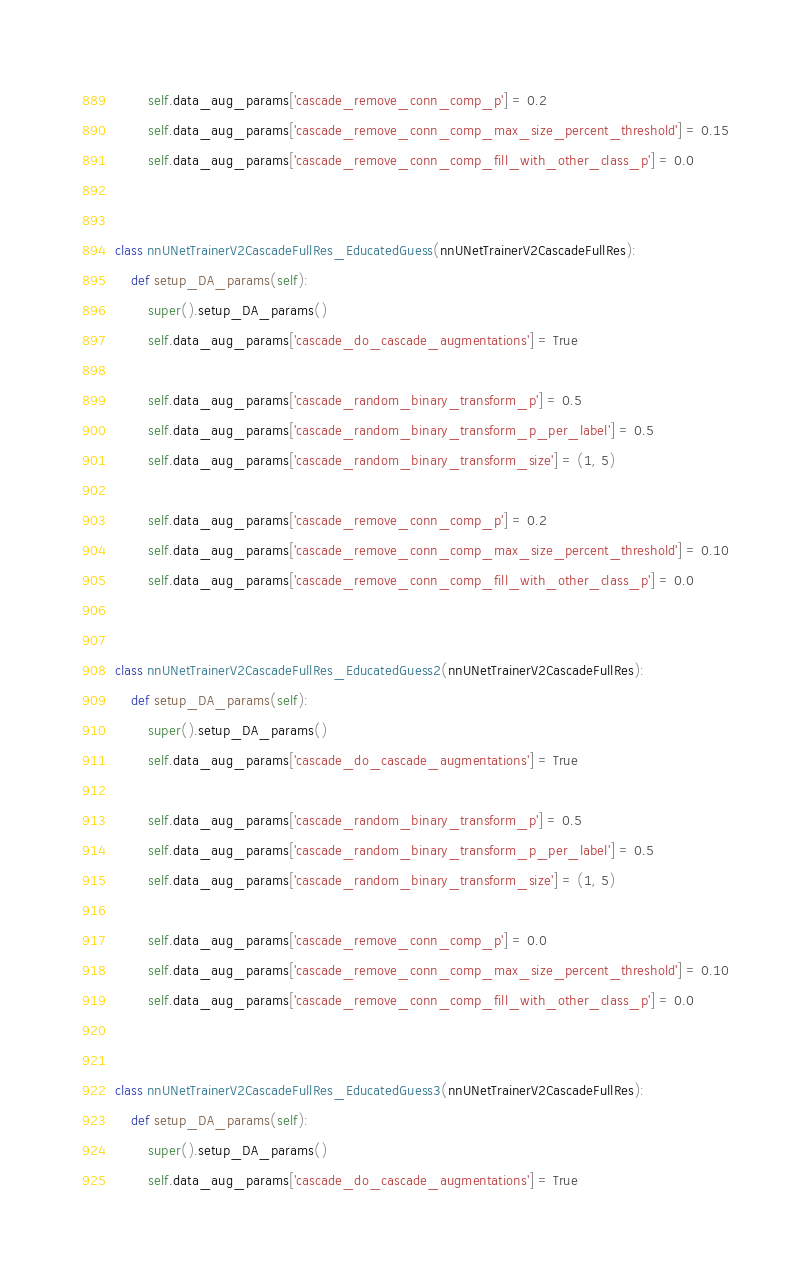<code> <loc_0><loc_0><loc_500><loc_500><_Python_>
        self.data_aug_params['cascade_remove_conn_comp_p'] = 0.2
        self.data_aug_params['cascade_remove_conn_comp_max_size_percent_threshold'] = 0.15
        self.data_aug_params['cascade_remove_conn_comp_fill_with_other_class_p'] = 0.0


class nnUNetTrainerV2CascadeFullRes_EducatedGuess(nnUNetTrainerV2CascadeFullRes):
    def setup_DA_params(self):
        super().setup_DA_params()
        self.data_aug_params['cascade_do_cascade_augmentations'] = True

        self.data_aug_params['cascade_random_binary_transform_p'] = 0.5
        self.data_aug_params['cascade_random_binary_transform_p_per_label'] = 0.5
        self.data_aug_params['cascade_random_binary_transform_size'] = (1, 5)

        self.data_aug_params['cascade_remove_conn_comp_p'] = 0.2
        self.data_aug_params['cascade_remove_conn_comp_max_size_percent_threshold'] = 0.10
        self.data_aug_params['cascade_remove_conn_comp_fill_with_other_class_p'] = 0.0


class nnUNetTrainerV2CascadeFullRes_EducatedGuess2(nnUNetTrainerV2CascadeFullRes):
    def setup_DA_params(self):
        super().setup_DA_params()
        self.data_aug_params['cascade_do_cascade_augmentations'] = True

        self.data_aug_params['cascade_random_binary_transform_p'] = 0.5
        self.data_aug_params['cascade_random_binary_transform_p_per_label'] = 0.5
        self.data_aug_params['cascade_random_binary_transform_size'] = (1, 5)

        self.data_aug_params['cascade_remove_conn_comp_p'] = 0.0
        self.data_aug_params['cascade_remove_conn_comp_max_size_percent_threshold'] = 0.10
        self.data_aug_params['cascade_remove_conn_comp_fill_with_other_class_p'] = 0.0


class nnUNetTrainerV2CascadeFullRes_EducatedGuess3(nnUNetTrainerV2CascadeFullRes):
    def setup_DA_params(self):
        super().setup_DA_params()
        self.data_aug_params['cascade_do_cascade_augmentations'] = True
</code> 